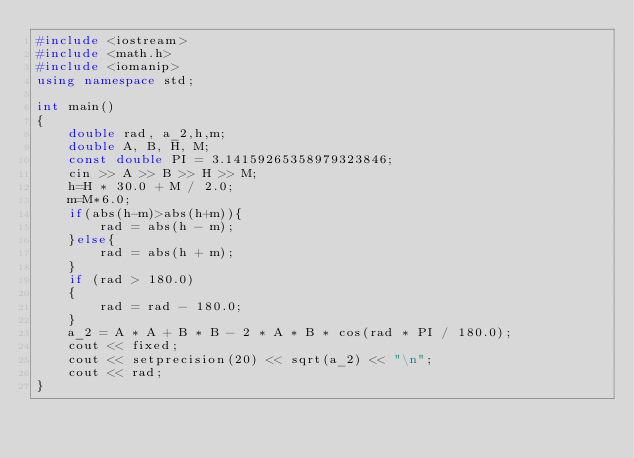Convert code to text. <code><loc_0><loc_0><loc_500><loc_500><_C++_>#include <iostream>
#include <math.h>
#include <iomanip>
using namespace std;

int main()
{
    double rad, a_2,h,m;
    double A, B, H, M;
    const double PI = 3.14159265358979323846;
    cin >> A >> B >> H >> M;
    h=H * 30.0 + M / 2.0;
    m=M*6.0; 
    if(abs(h-m)>abs(h+m)){
        rad = abs(h - m);
    }else{
        rad = abs(h + m);
    }
    if (rad > 180.0)
    {
        rad = rad - 180.0;
    }
    a_2 = A * A + B * B - 2 * A * B * cos(rad * PI / 180.0);
    cout << fixed;
    cout << setprecision(20) << sqrt(a_2) << "\n";
    cout << rad;
}</code> 